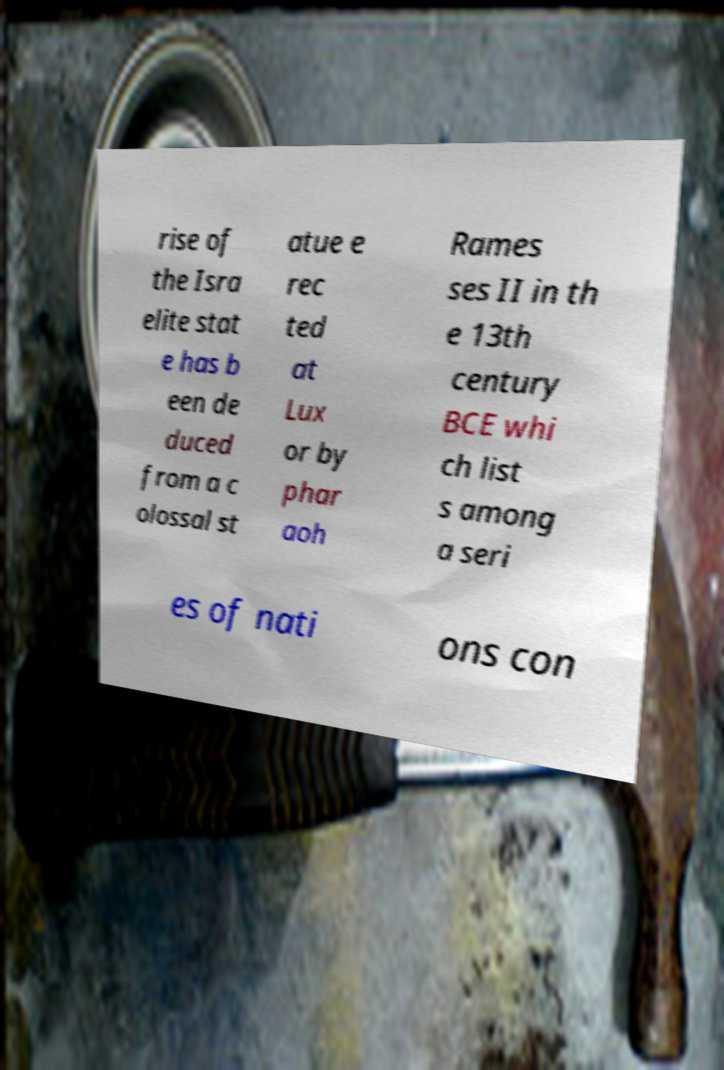Could you assist in decoding the text presented in this image and type it out clearly? rise of the Isra elite stat e has b een de duced from a c olossal st atue e rec ted at Lux or by phar aoh Rames ses II in th e 13th century BCE whi ch list s among a seri es of nati ons con 